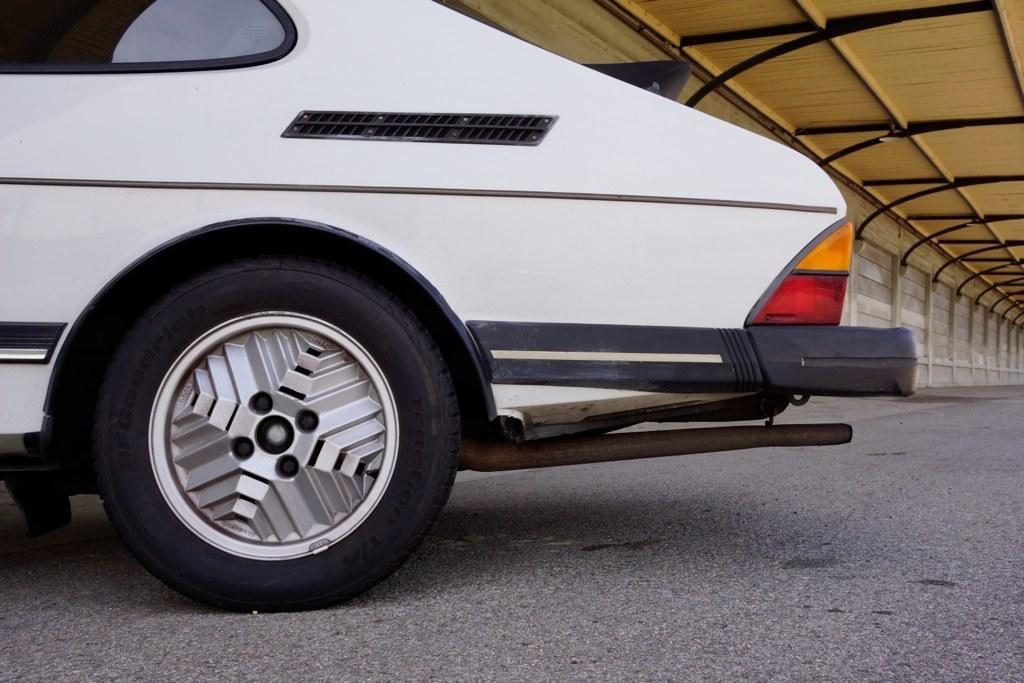What color is the car in the image? The car in the image is white. Where is the car located in the image? The car is on the road in the image. What can be seen in the background of the image? There is a wall and a roof visible in the background of the image. What effect does the car have on the bit in the image? There is no bit present in the image, so it is not possible to determine any effect the car might have on it. 